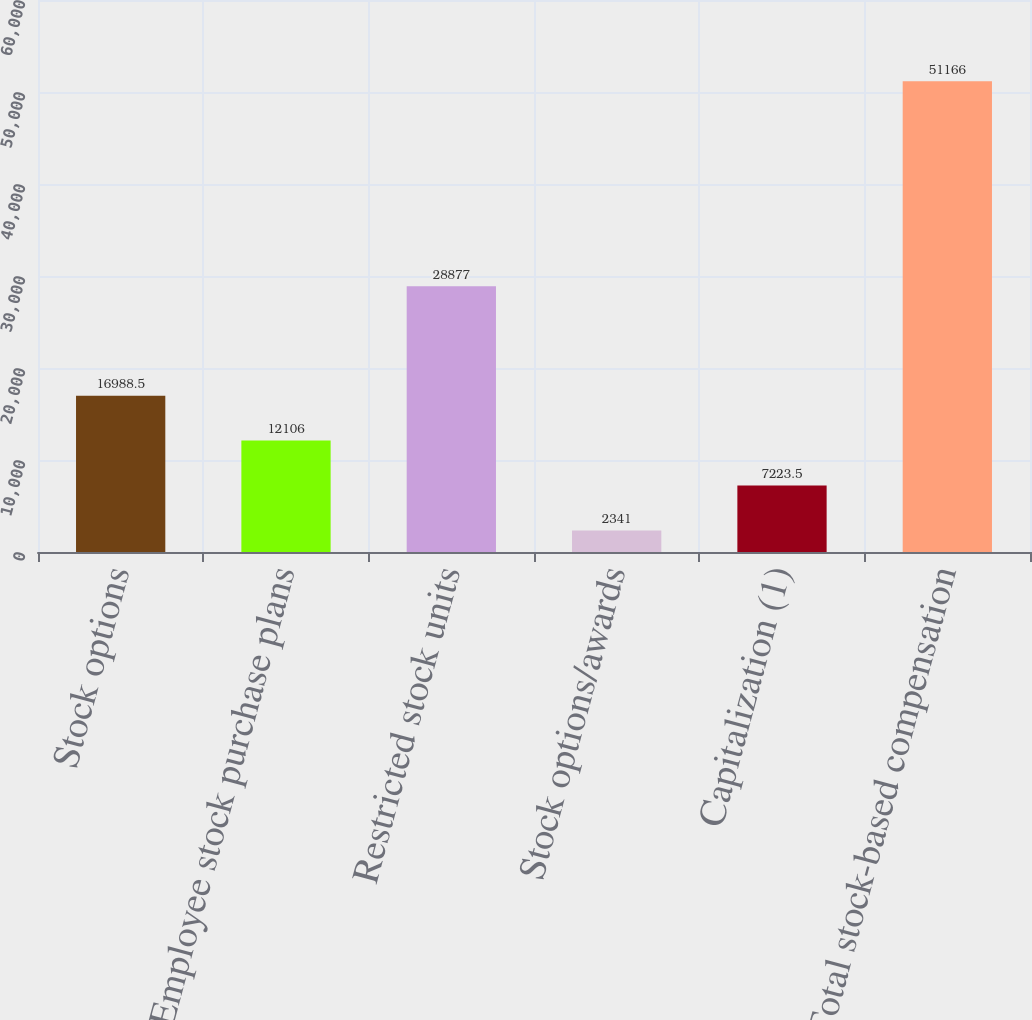<chart> <loc_0><loc_0><loc_500><loc_500><bar_chart><fcel>Stock options<fcel>Employee stock purchase plans<fcel>Restricted stock units<fcel>Stock options/awards<fcel>Capitalization (1)<fcel>Total stock-based compensation<nl><fcel>16988.5<fcel>12106<fcel>28877<fcel>2341<fcel>7223.5<fcel>51166<nl></chart> 